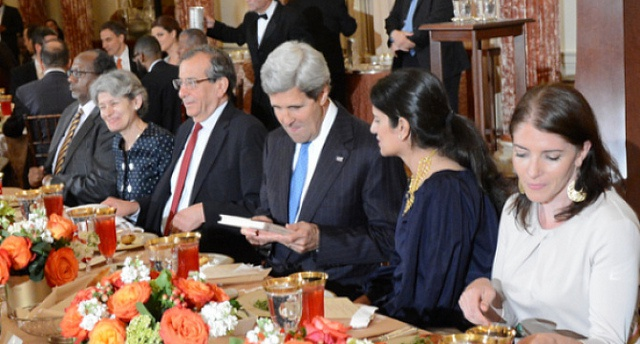Describe the objects in this image and their specific colors. I can see dining table in maroon, tan, and white tones, people in maroon, lightgray, pink, black, and darkgray tones, people in maroon, black, darkgray, and gray tones, people in maroon, black, navy, tan, and gray tones, and people in maroon, black, lightpink, and white tones in this image. 